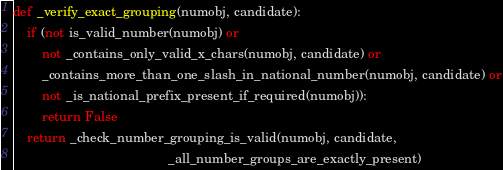Convert code to text. <code><loc_0><loc_0><loc_500><loc_500><_Python_>
def _verify_exact_grouping(numobj, candidate):
    if (not is_valid_number(numobj) or
        not _contains_only_valid_x_chars(numobj, candidate) or
        _contains_more_than_one_slash_in_national_number(numobj, candidate) or
        not _is_national_prefix_present_if_required(numobj)):
        return False
    return _check_number_grouping_is_valid(numobj, candidate,
                                           _all_number_groups_are_exactly_present)

</code> 